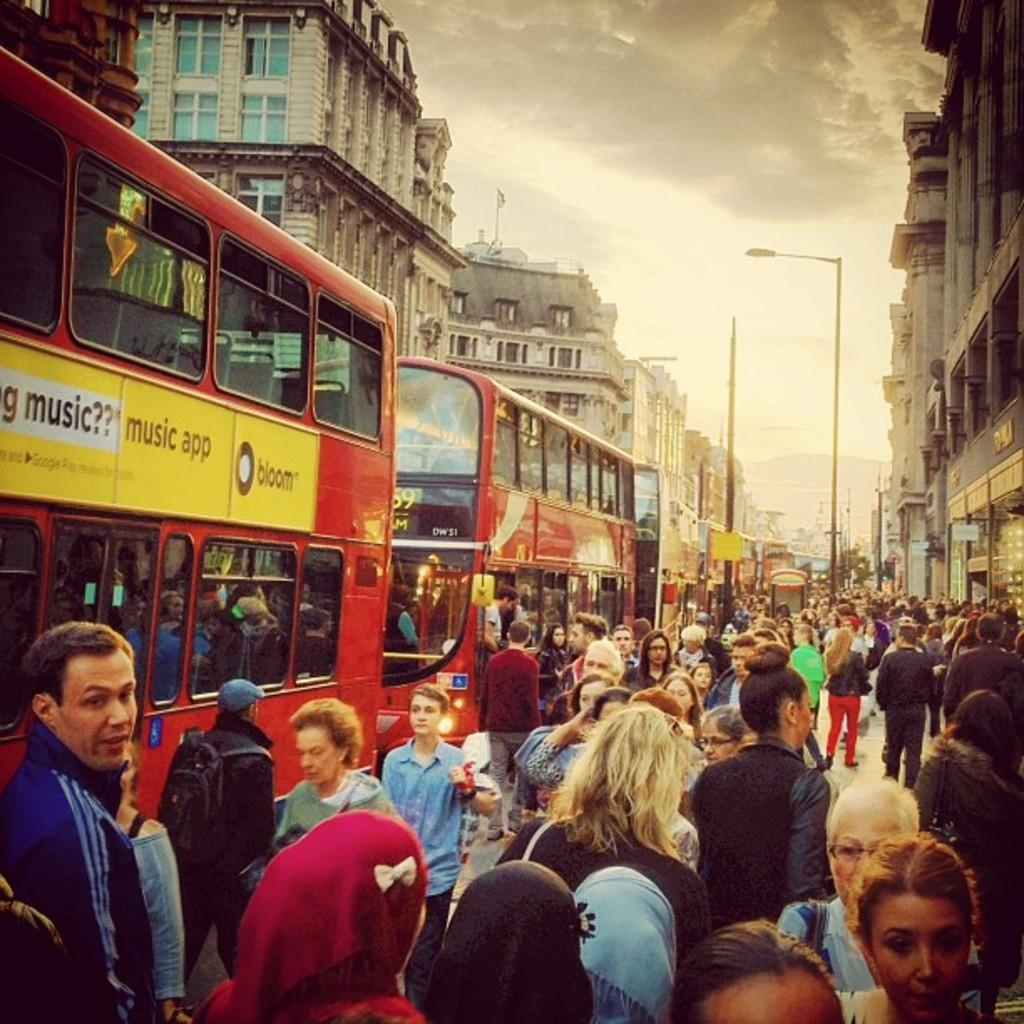What can be seen in the image in terms of people and vehicles? There are crowds of people and buses in the image. What structures are present in the image? There are street lights, poles, and buildings in the image. What part of the natural environment is visible in the image? The sky is visible in the image. What type of songs can be heard coming from the scarecrow in the image? There is no scarecrow present in the image, so it is not possible to determine what, if any, songs might be heard. 